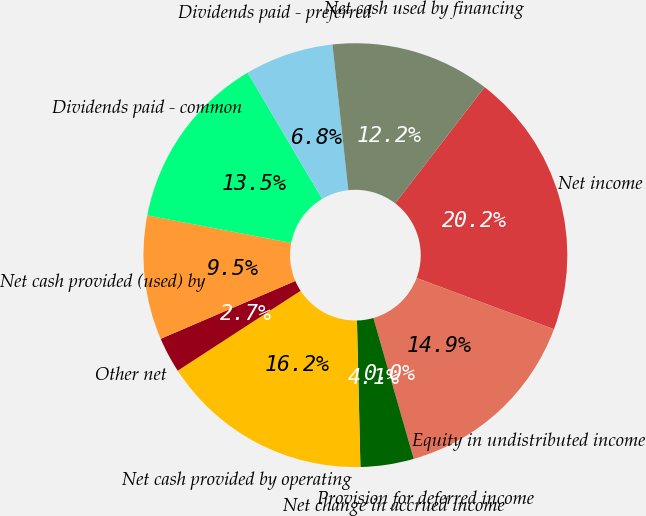Convert chart to OTSL. <chart><loc_0><loc_0><loc_500><loc_500><pie_chart><fcel>Net income<fcel>Equity in undistributed income<fcel>Provision for deferred income<fcel>Net change in accrued income<fcel>Net cash provided by operating<fcel>Other net<fcel>Net cash provided (used) by<fcel>Dividends paid - common<fcel>Dividends paid - preferred<fcel>Net cash used by financing<nl><fcel>20.25%<fcel>14.86%<fcel>0.02%<fcel>4.06%<fcel>16.2%<fcel>2.72%<fcel>9.46%<fcel>13.51%<fcel>6.76%<fcel>12.16%<nl></chart> 